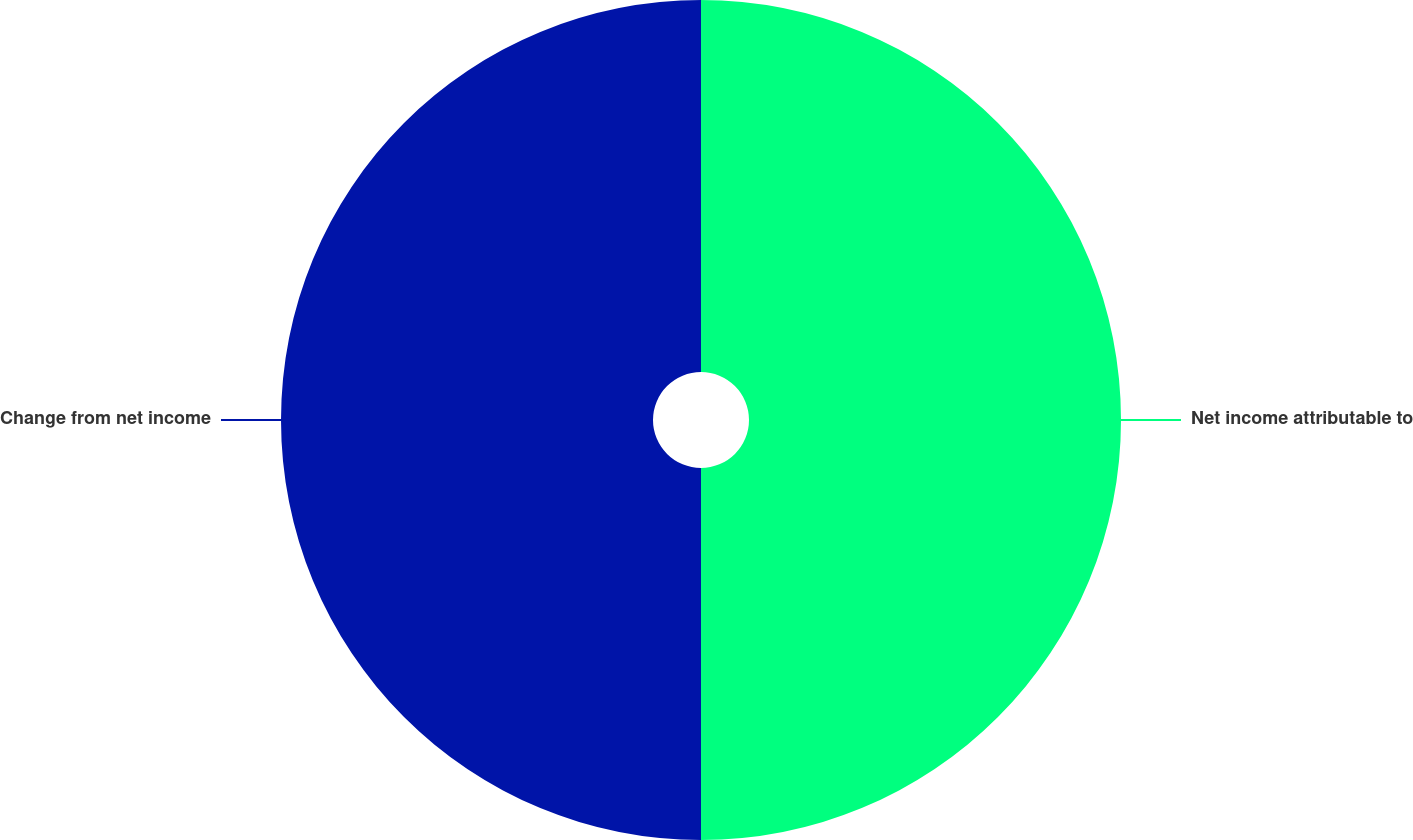<chart> <loc_0><loc_0><loc_500><loc_500><pie_chart><fcel>Net income attributable to<fcel>Change from net income<nl><fcel>50.0%<fcel>50.0%<nl></chart> 